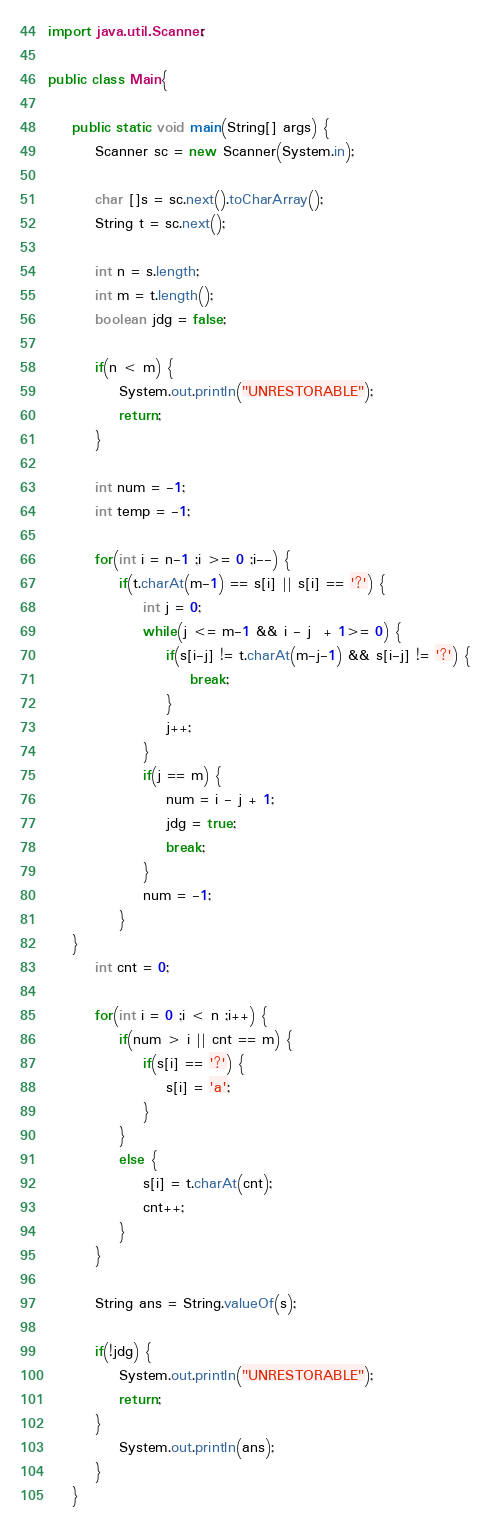Convert code to text. <code><loc_0><loc_0><loc_500><loc_500><_Java_>
import java.util.Scanner;

public class Main{

	public static void main(String[] args) {
		Scanner sc = new Scanner(System.in);
		
		char []s = sc.next().toCharArray();
		String t = sc.next();
		
		int n = s.length;
		int m = t.length();
		boolean jdg = false;
		
		if(n < m) {
			System.out.println("UNRESTORABLE");
			return;
		}
		
		int num = -1;
		int temp = -1;
		
		for(int i = n-1 ;i >= 0 ;i--) {
			if(t.charAt(m-1) == s[i] || s[i] == '?') {
				int j = 0;
				while(j <= m-1 && i - j  + 1>= 0) {
					if(s[i-j] != t.charAt(m-j-1) && s[i-j] != '?') {
						break;
					}
					j++;
				}
				if(j == m) {
					num = i - j + 1;
					jdg = true;
					break;
				}
				num = -1;
			}
	}
		int cnt = 0;
		
		for(int i = 0 ;i < n ;i++) {
			if(num > i || cnt == m) {
				if(s[i] == '?') {
					s[i] = 'a';
				}
			}
			else {
				s[i] = t.charAt(cnt);
				cnt++;
			}
		}
		
		String ans = String.valueOf(s);
		
		if(!jdg) {
			System.out.println("UNRESTORABLE");
			return;
		}
			System.out.println(ans);
		}
	}

</code> 